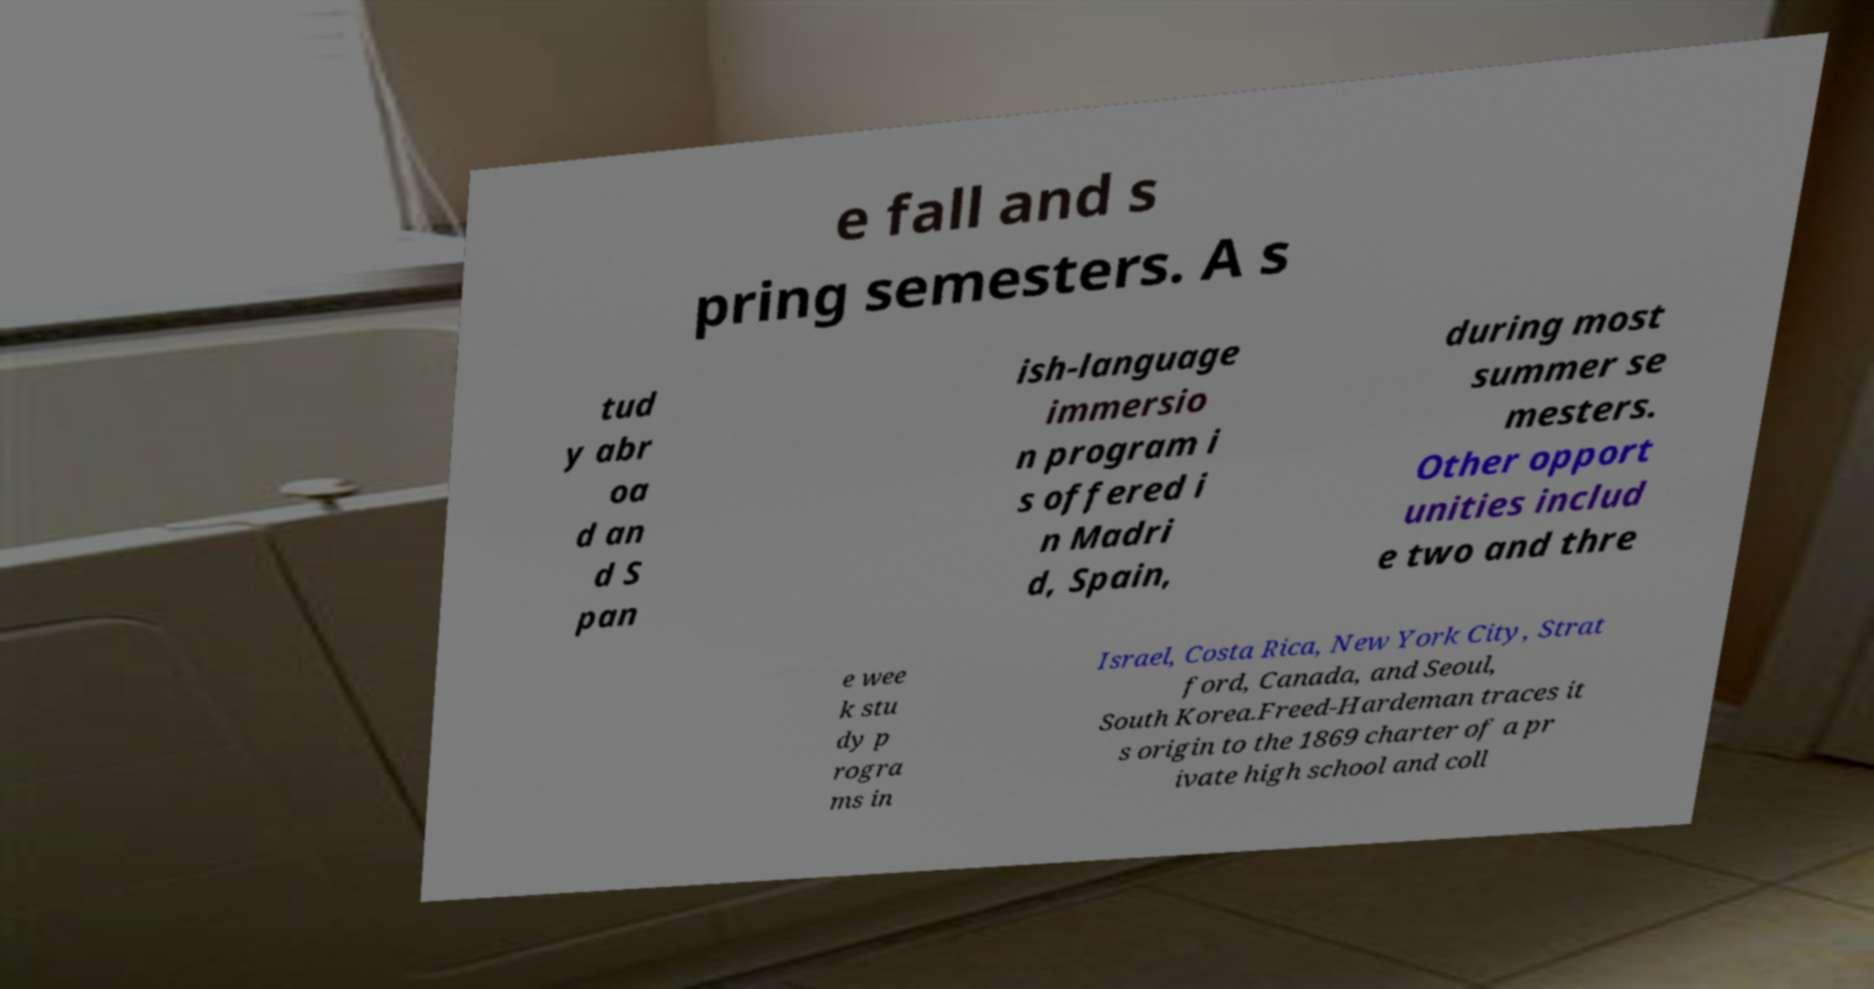Could you assist in decoding the text presented in this image and type it out clearly? e fall and s pring semesters. A s tud y abr oa d an d S pan ish-language immersio n program i s offered i n Madri d, Spain, during most summer se mesters. Other opport unities includ e two and thre e wee k stu dy p rogra ms in Israel, Costa Rica, New York City, Strat ford, Canada, and Seoul, South Korea.Freed-Hardeman traces it s origin to the 1869 charter of a pr ivate high school and coll 